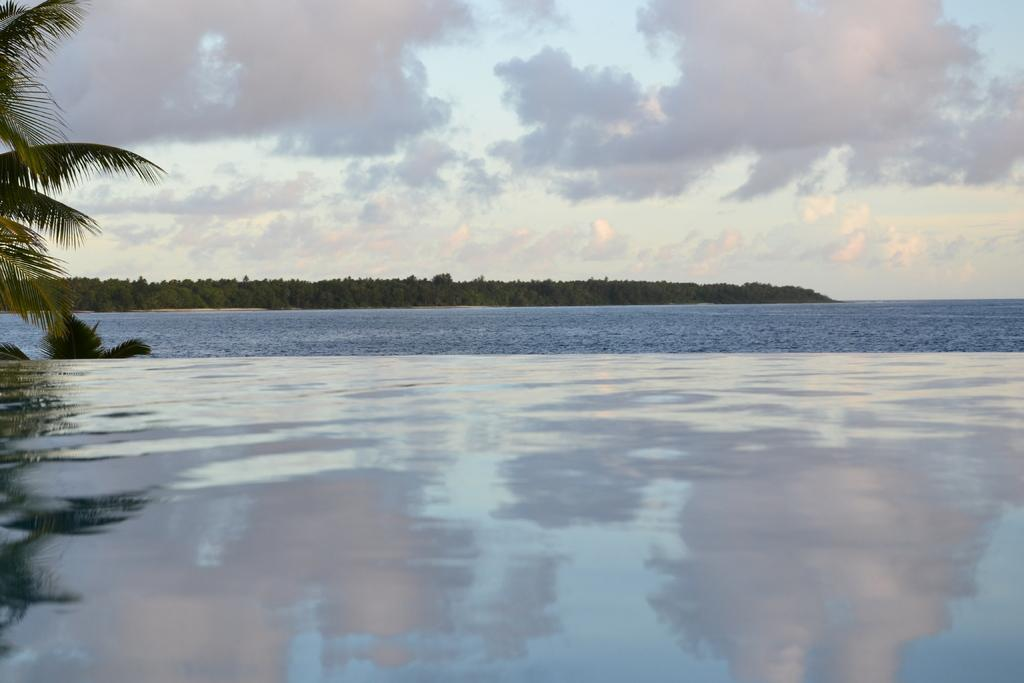What is at the bottom of the image? There are waves and water at the bottom of the image. What can be seen on the left side of the image? There are trees on the left side of the image. What is visible in the background of the image? Trees, water, and the sky are visible in the background of the image. What can be observed in the sky in the image? Clouds are present in the background of the image. What type of lace can be seen in the image? There is no lace present in the image. What kind of destruction is depicted in the image? There is no destruction depicted in the image; it features natural elements such as trees, water, and clouds. 